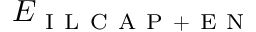<formula> <loc_0><loc_0><loc_500><loc_500>E _ { I L C A P + E N }</formula> 